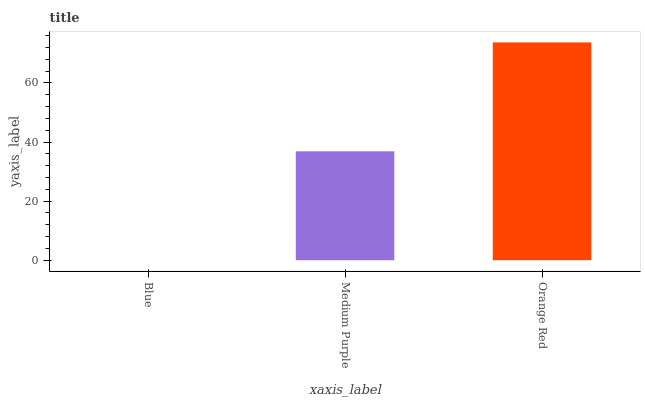Is Blue the minimum?
Answer yes or no. Yes. Is Orange Red the maximum?
Answer yes or no. Yes. Is Medium Purple the minimum?
Answer yes or no. No. Is Medium Purple the maximum?
Answer yes or no. No. Is Medium Purple greater than Blue?
Answer yes or no. Yes. Is Blue less than Medium Purple?
Answer yes or no. Yes. Is Blue greater than Medium Purple?
Answer yes or no. No. Is Medium Purple less than Blue?
Answer yes or no. No. Is Medium Purple the high median?
Answer yes or no. Yes. Is Medium Purple the low median?
Answer yes or no. Yes. Is Orange Red the high median?
Answer yes or no. No. Is Orange Red the low median?
Answer yes or no. No. 